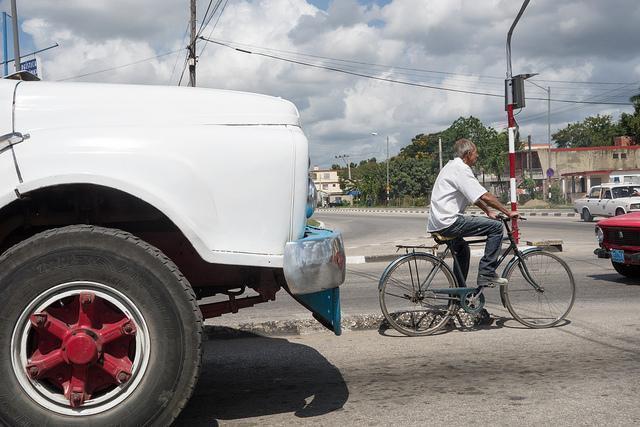How many cars are there?
Give a very brief answer. 2. 